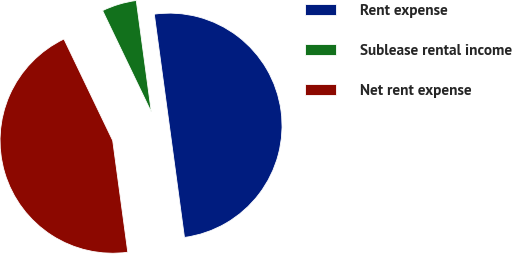Convert chart. <chart><loc_0><loc_0><loc_500><loc_500><pie_chart><fcel>Rent expense<fcel>Sublease rental income<fcel>Net rent expense<nl><fcel>50.0%<fcel>4.99%<fcel>45.01%<nl></chart> 